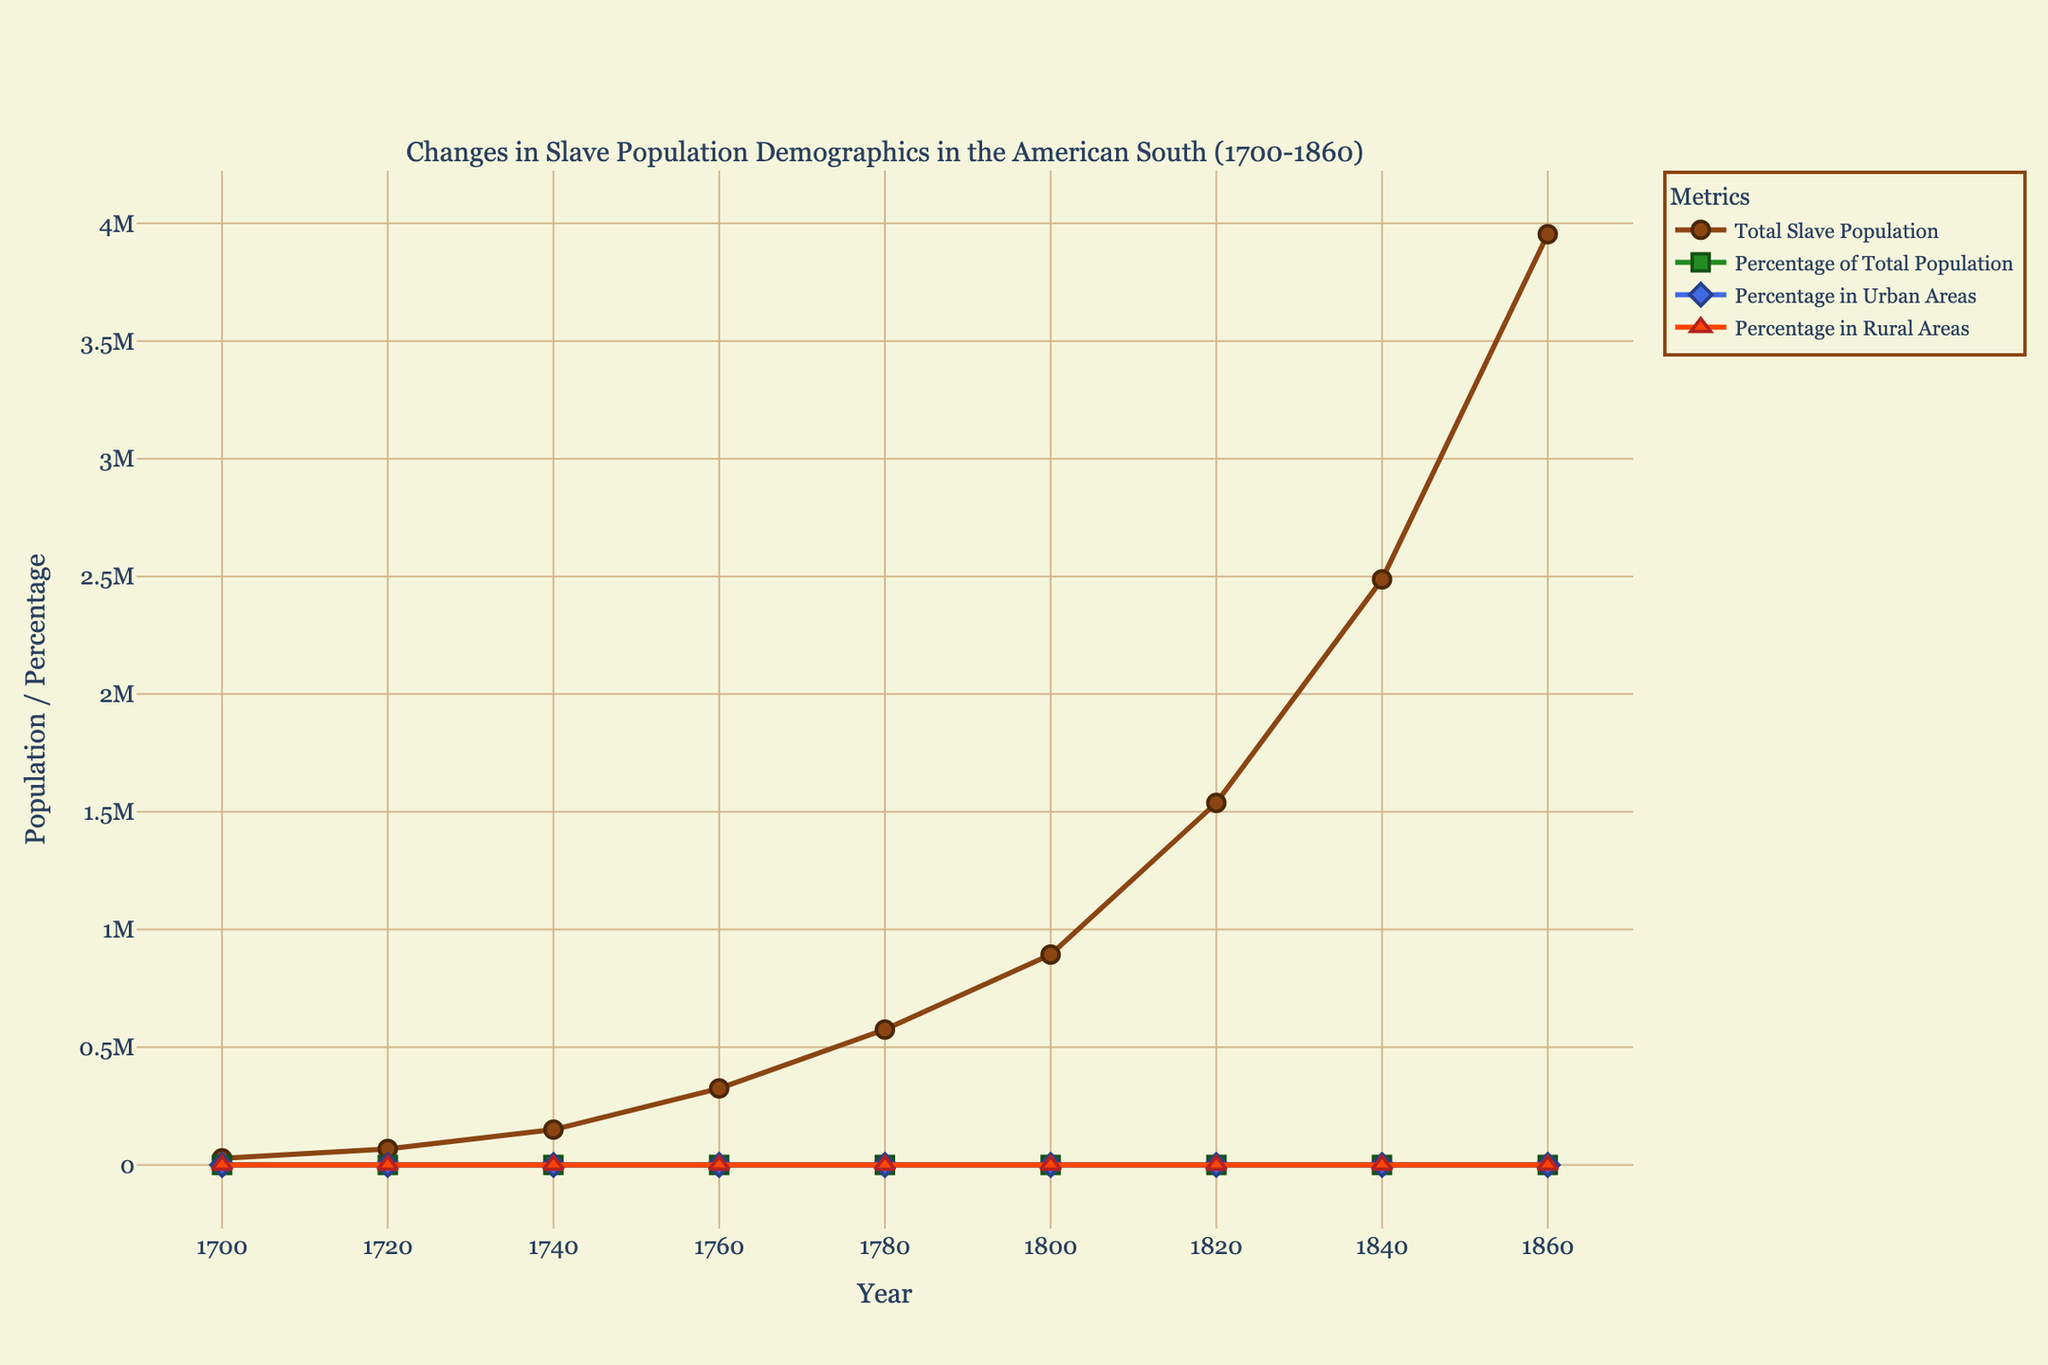What is the total increase in the slave population from 1700 to 1860? To find the total increase, subtract the slave population in 1700 from that in 1860. Slave population in 1700 was 28,000, and in 1860 it was 3,953,760. So, 3,953,760 - 28,000 = 3,925,760
Answer: 3,925,760 During which decade did the percentage of the total population reach its peak? Observe the trend line for the percentage of the total population. The peak value is seen in the 1800s, where the percentage is 38%
Answer: 1800s In which year was the percentage of slaves in urban areas closest to 4%? Find the point closest to 4% on the Percentage in Urban Areas line. This value is reached in 1740
Answer: 1740 How did the percentage of slaves in rural areas change from 1700 to 1860? Compare the percentage of slaves in rural areas for 1700 and 1860. In 1700, it was 98%, and in 1860, it was 90%. This shows a decline of 8%
Answer: Decreased by 8% Which segment (urban or rural) saw a higher percentage increase in the slave population from 1700 to 1860? Calculate the percentage points change for both segments: rural from 98% to 90% (a decrease of 8%) and urban from 2% to 10% (an increase of 8%). The urban areas saw an increase while rural saw a decrease
Answer: Urban What was the trend of the total slave population from 1700 to 1860? The trend line for the total slave population shows a continuous increase from 28,000 in 1700 to 3,953,760 in 1860
Answer: Increasing In which year was the percentage difference between rural and urban slave populations the largest? Look for the year with the biggest gap between the Percentage in Rural Areas and the Percentage in Urban Areas lines. The largest difference is in 1700, with rural at 98% and urban at 2%, making the difference 96%
Answer: 1700 What is the average percentage of slaves in urban areas across all the years provided? Add up the urban area percentages and divide by the number of years: (2 + 3 + 4 + 5 + 6 + 7 + 8 + 9 + 10) / 9 = 54 / 9 = 6%
Answer: 6% Did the percentage of the total slave population ever decrease after reaching its peak? If yes, in which decades? Observe the trend line for the percentage of the total population after it peaks in 1800. It decreases in the 1820s and 1840s
Answer: 1820s and 1840s Which metric showed a more consistent trend throughout the years, the percentage of slaves in urban areas, or rural areas? By looking at the two lines representing urban and rural percentages, rural areas show a more consistent downward trend, while urban areas show a consistent upward trend. However, the rural trend is more stable compared to the fluctuations seen in urban percentages
Answer: Rural areas 